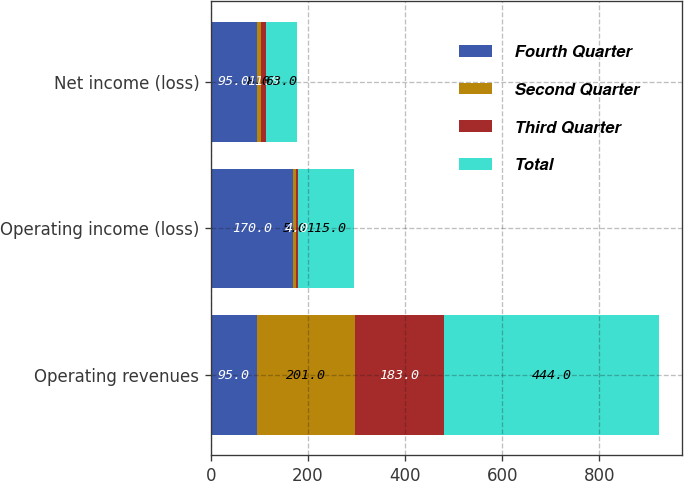Convert chart to OTSL. <chart><loc_0><loc_0><loc_500><loc_500><stacked_bar_chart><ecel><fcel>Operating revenues<fcel>Operating income (loss)<fcel>Net income (loss)<nl><fcel>Fourth Quarter<fcel>95<fcel>170<fcel>95<nl><fcel>Second Quarter<fcel>201<fcel>5<fcel>8<nl><fcel>Third Quarter<fcel>183<fcel>4<fcel>11<nl><fcel>Total<fcel>444<fcel>115<fcel>63<nl></chart> 